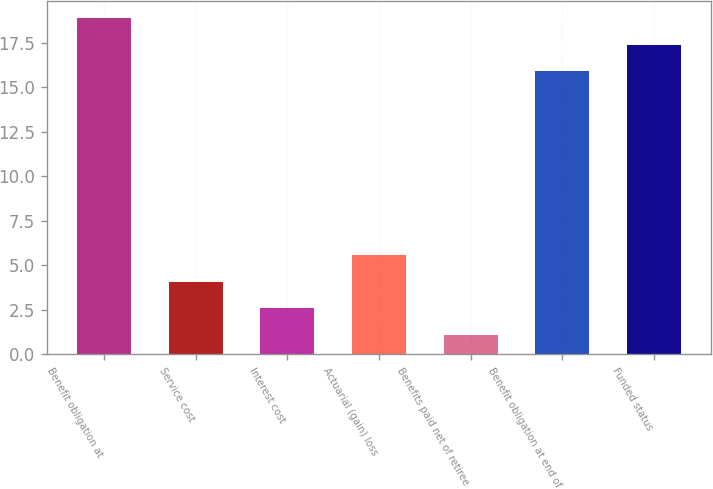Convert chart. <chart><loc_0><loc_0><loc_500><loc_500><bar_chart><fcel>Benefit obligation at<fcel>Service cost<fcel>Interest cost<fcel>Actuarial (gain) loss<fcel>Benefits paid net of retiree<fcel>Benefit obligation at end of<fcel>Funded status<nl><fcel>18.88<fcel>4.08<fcel>2.59<fcel>5.57<fcel>1.1<fcel>15.9<fcel>17.39<nl></chart> 